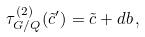<formula> <loc_0><loc_0><loc_500><loc_500>\tau _ { G / Q } ^ { ( 2 ) } ( \tilde { c } ^ { \prime } ) = \tilde { c } + d b \, ,</formula> 